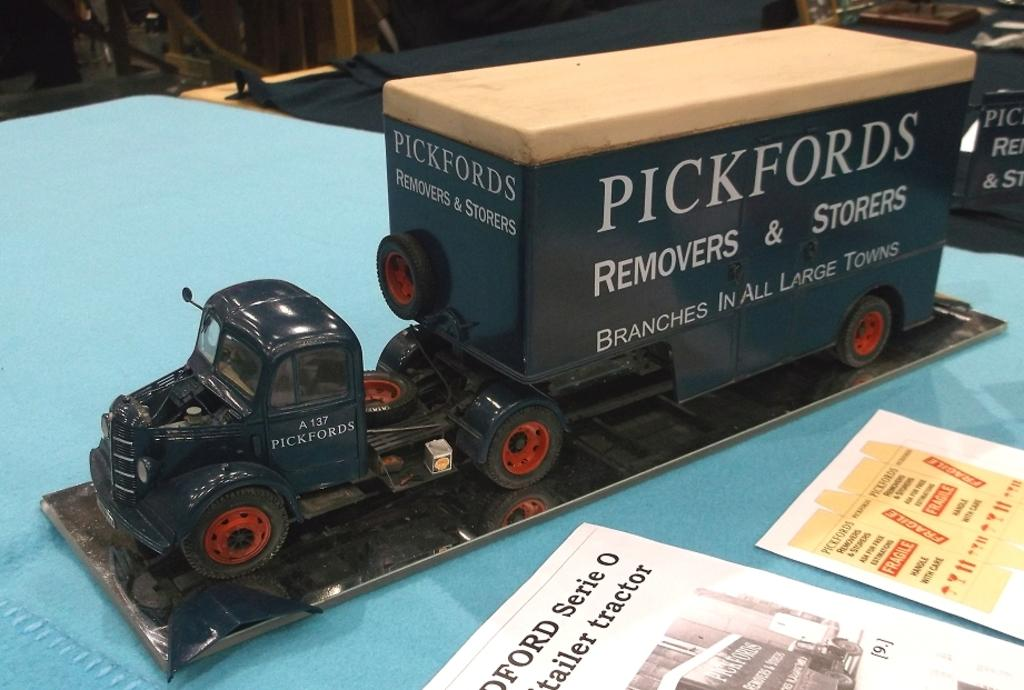What type of toy is in the picture? There is a toy truck in the picture. What is on the table in the picture? There are papers on the table in the picture. Can you describe the content of the papers? There is text visible on the papers. What type of lamp is hanging above the toy truck in the picture? There is no lamp present in the picture; it only features a toy truck and papers on a table. 